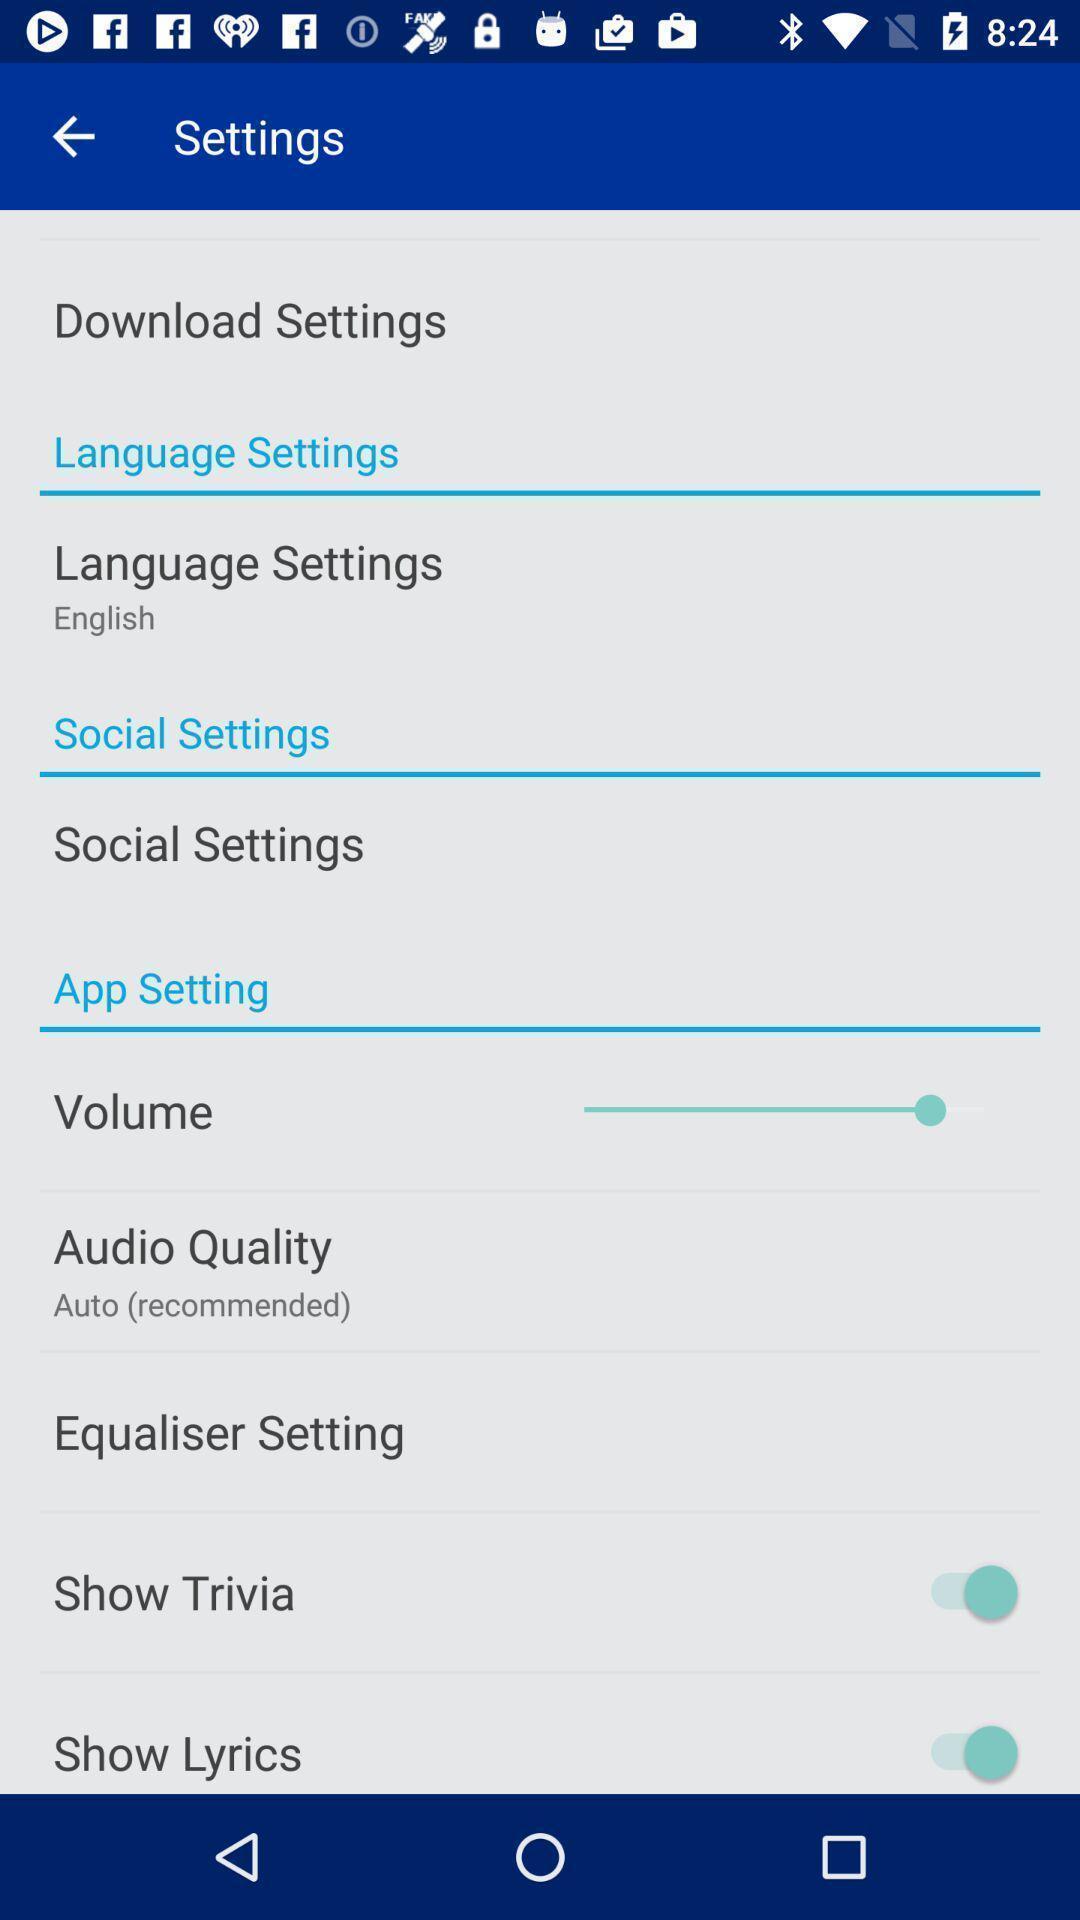Provide a detailed account of this screenshot. Settings page with options in the music player app. 